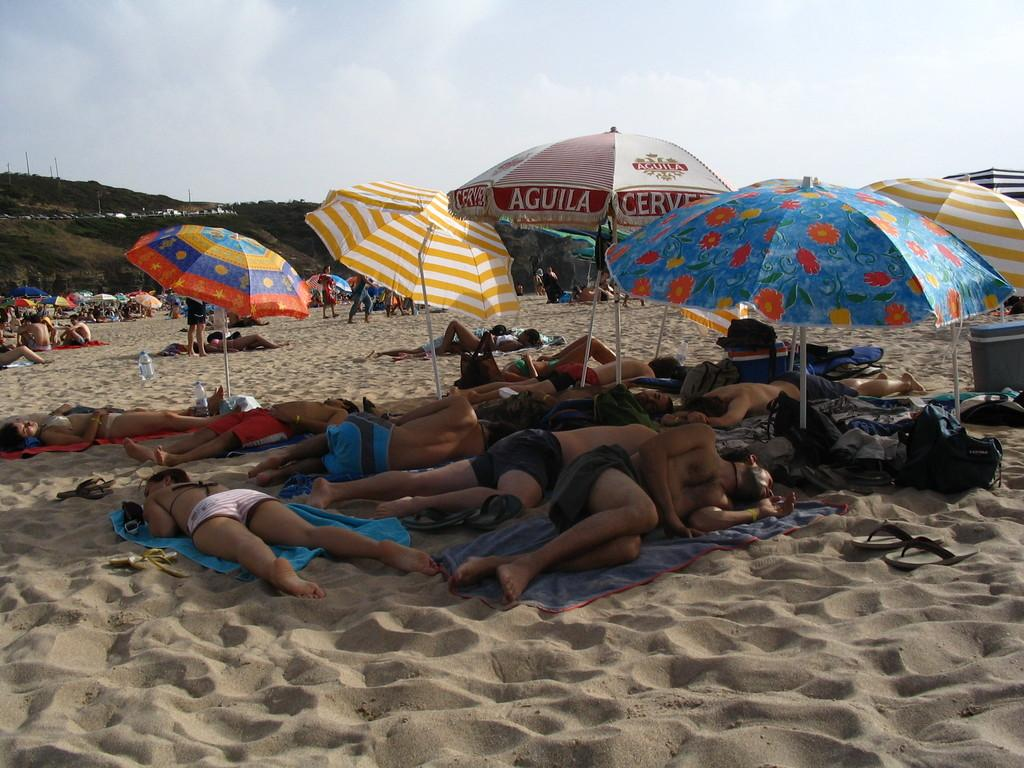What are the people lying on in the image? The people are lying on the sand surface. What are the other people doing in the image? Some people are standing and sitting behind them. What can be seen on the sand surface besides the people? There are umbrellas on the sand surface. What books are the people reading on the sand surface? There are no books present in the image; the people are lying on the sand surface. What is causing the people to express anger in the image? There is no indication of anger or any negative emotions in the image; the people are simply lying, standing, or sitting on the sand surface. 